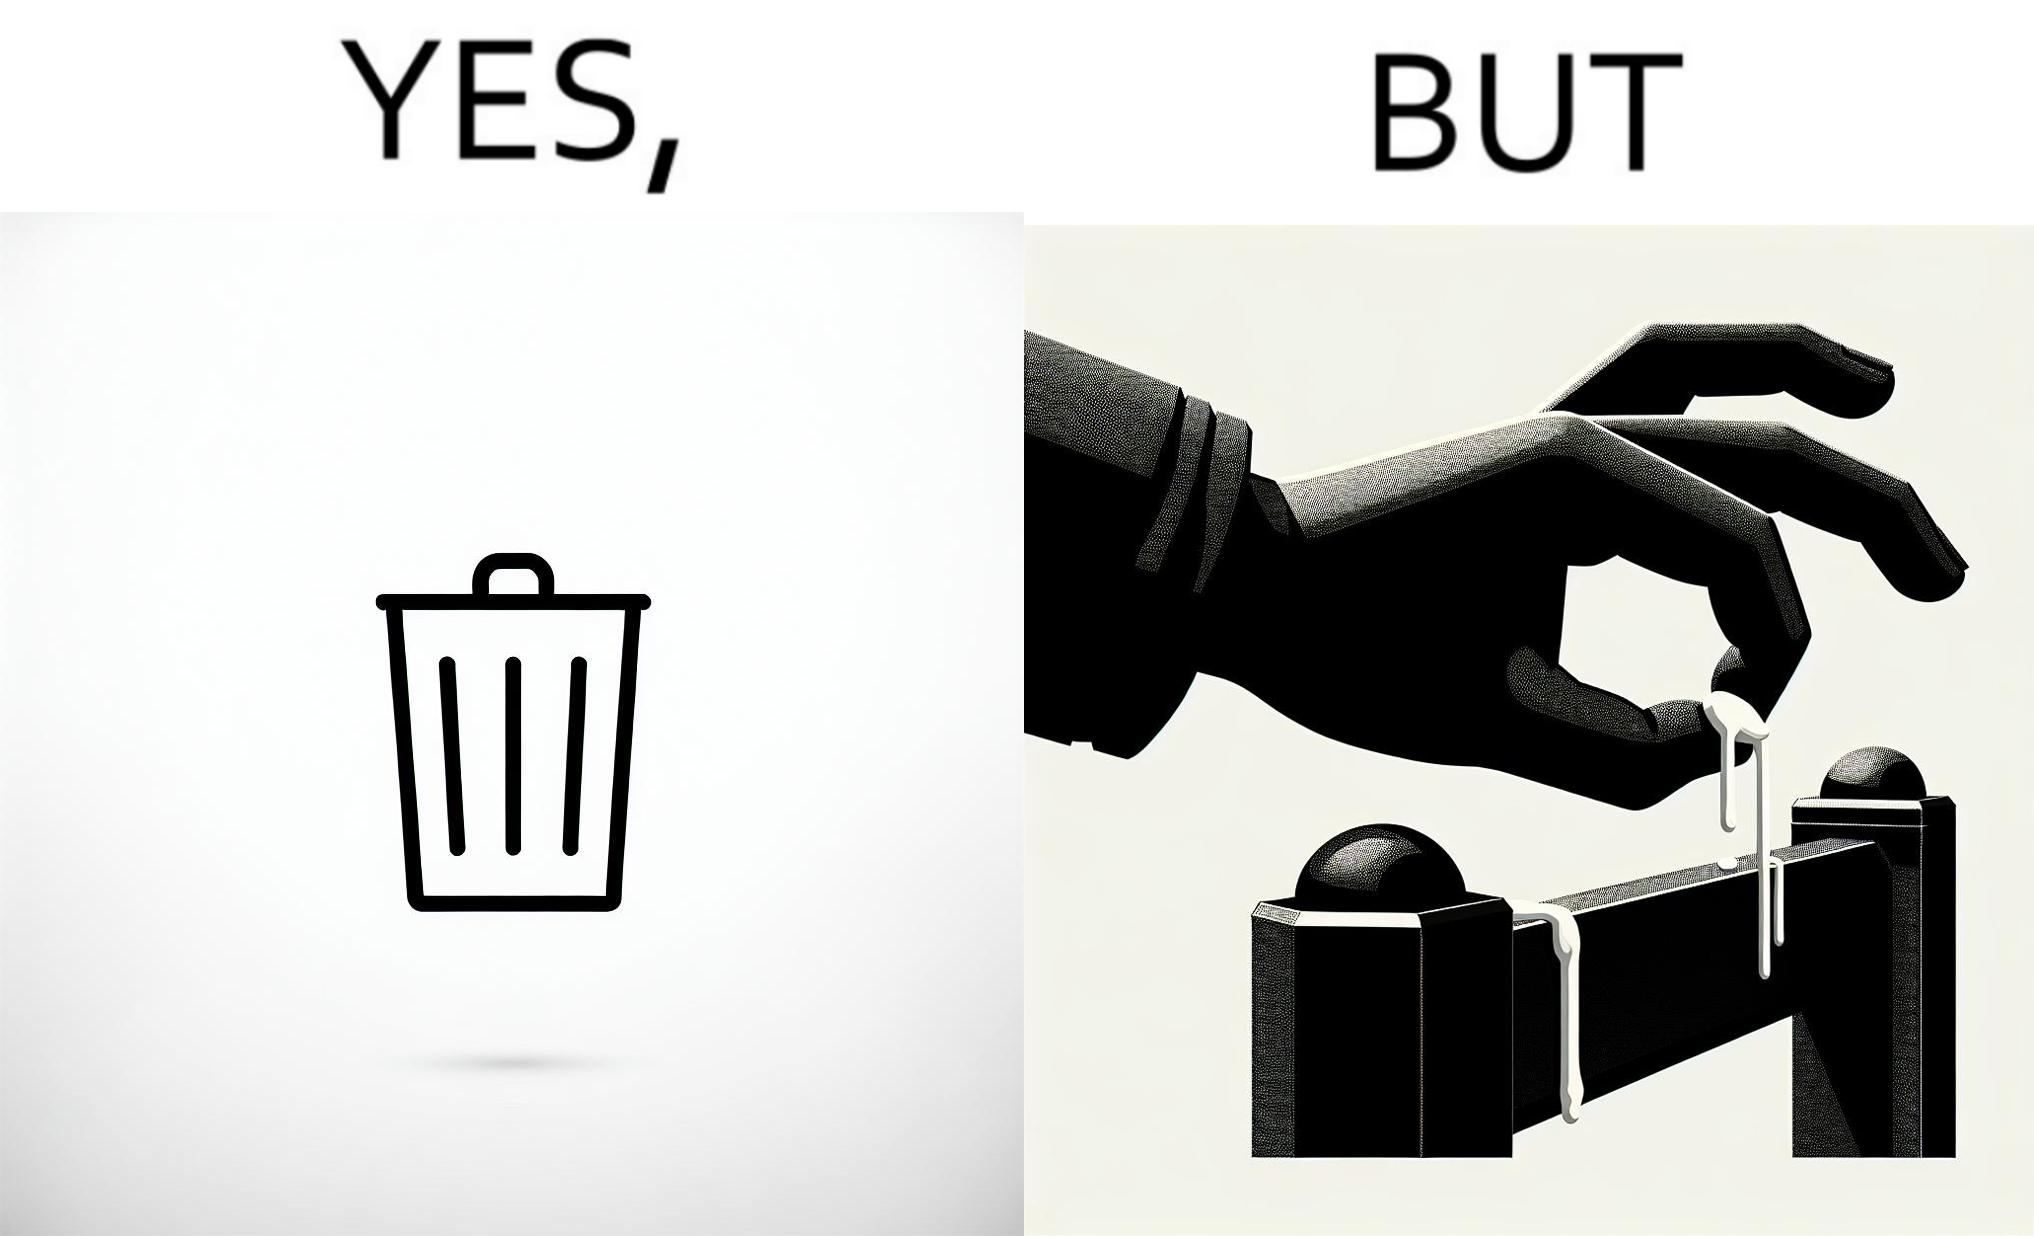Does this image contain satire or humor? Yes, this image is satirical. 